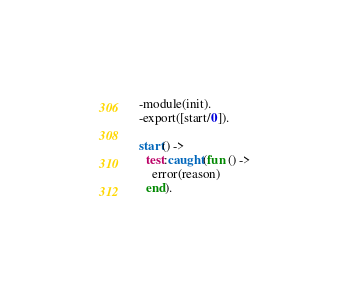<code> <loc_0><loc_0><loc_500><loc_500><_Erlang_>-module(init).
-export([start/0]).

start() ->
  test:caught(fun () ->
    error(reason)
  end).
</code> 